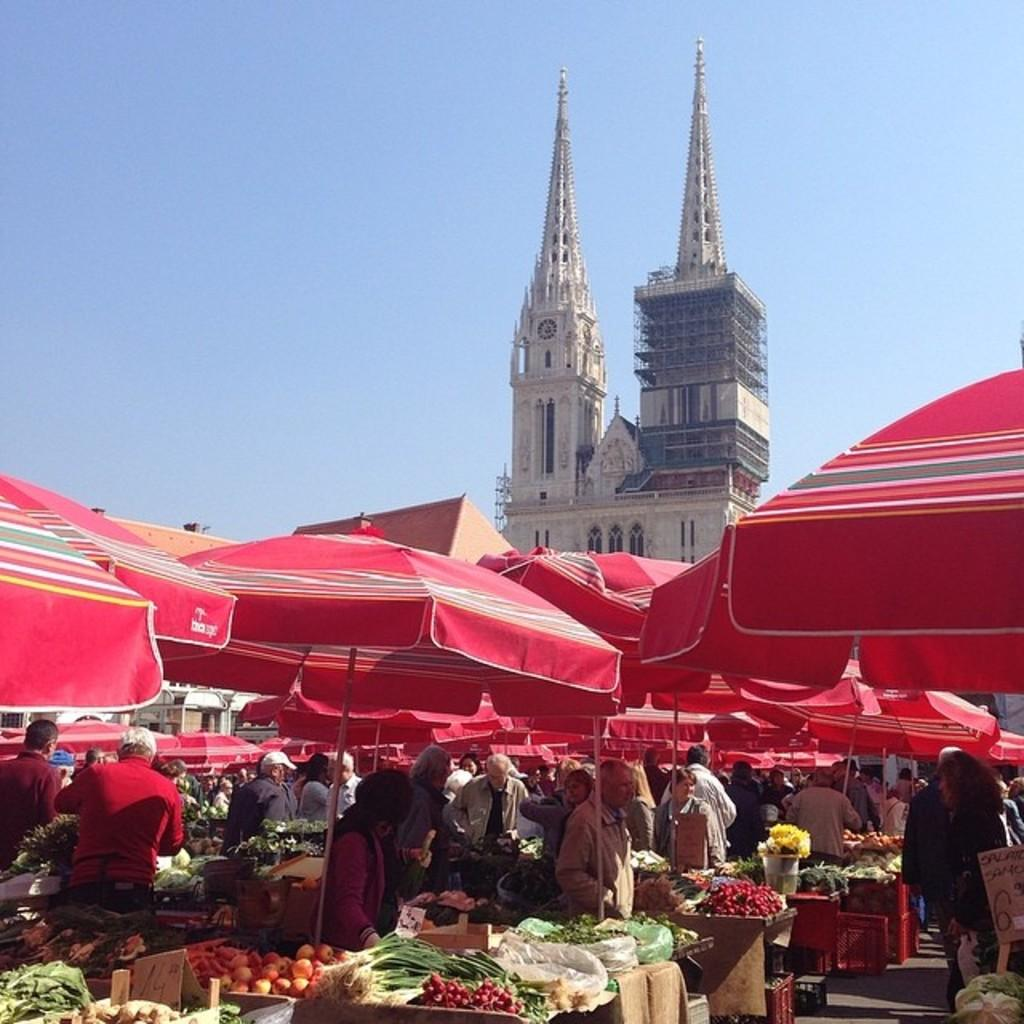What is located in the center of the image? There are tents in the center of the image. What can be seen at the bottom of the image? There are tables at the bottom of the image. What is on the tables in the image? Vegetables are visible on the tables. Are there any people in the image? Yes, there are people standing in the image. What is visible in the background of the image? There is a tower and the sky in the background of the image. What type of teeth can be seen on the dinosaurs in the image? There are no dinosaurs present in the image, so there are no teeth to observe. Who is the creator of the tents in the image? The facts provided do not mention the creator of the tents, so it cannot be determined from the image. 